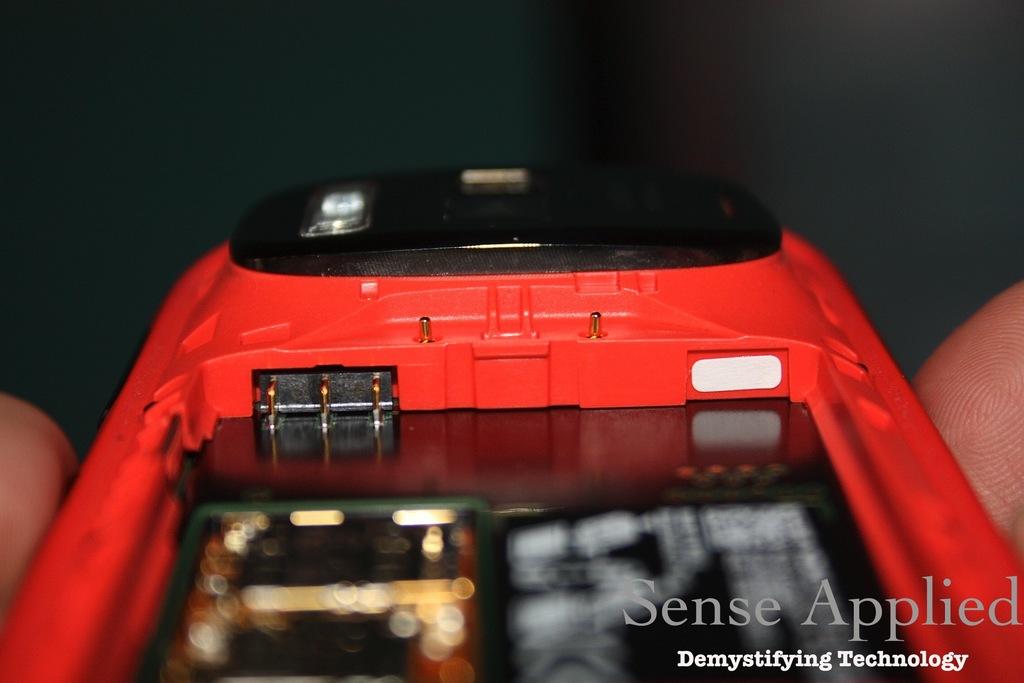What text is displayed as a watermark?
Offer a very short reply. Sense applied demystifying technology. 